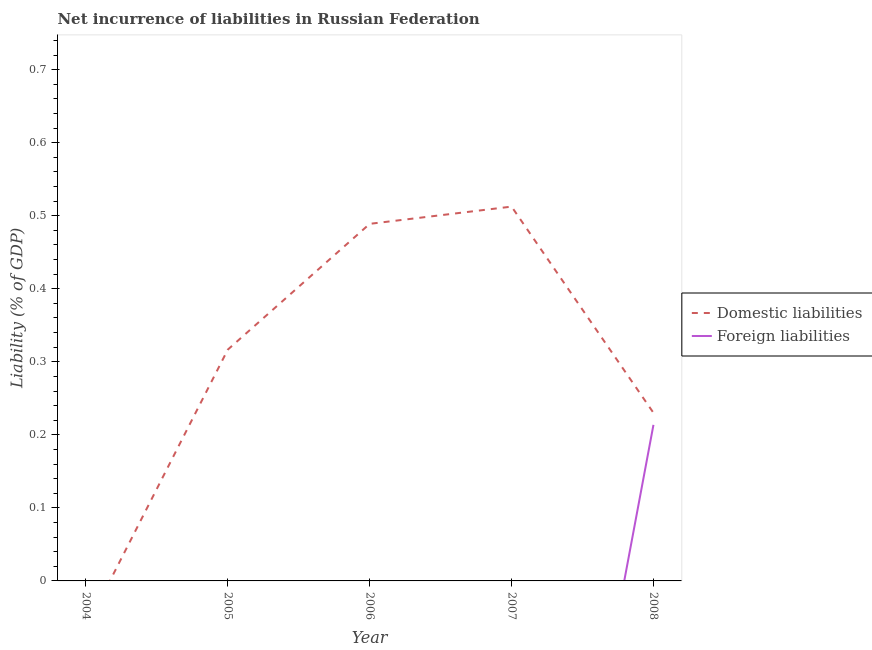How many different coloured lines are there?
Offer a terse response. 2. Does the line corresponding to incurrence of foreign liabilities intersect with the line corresponding to incurrence of domestic liabilities?
Ensure brevity in your answer.  No. What is the incurrence of foreign liabilities in 2008?
Give a very brief answer. 0.21. Across all years, what is the maximum incurrence of foreign liabilities?
Provide a succinct answer. 0.21. Across all years, what is the minimum incurrence of domestic liabilities?
Ensure brevity in your answer.  0. In which year was the incurrence of domestic liabilities maximum?
Your answer should be very brief. 2007. What is the total incurrence of foreign liabilities in the graph?
Keep it short and to the point. 0.21. What is the difference between the incurrence of domestic liabilities in 2005 and that in 2007?
Provide a succinct answer. -0.2. What is the average incurrence of foreign liabilities per year?
Offer a terse response. 0.04. In the year 2008, what is the difference between the incurrence of domestic liabilities and incurrence of foreign liabilities?
Keep it short and to the point. 0.02. In how many years, is the incurrence of domestic liabilities greater than 0.04 %?
Give a very brief answer. 4. What is the difference between the highest and the second highest incurrence of domestic liabilities?
Give a very brief answer. 0.02. What is the difference between the highest and the lowest incurrence of domestic liabilities?
Offer a very short reply. 0.51. Is the sum of the incurrence of domestic liabilities in 2006 and 2008 greater than the maximum incurrence of foreign liabilities across all years?
Ensure brevity in your answer.  Yes. Does the incurrence of domestic liabilities monotonically increase over the years?
Your answer should be very brief. No. Is the incurrence of domestic liabilities strictly less than the incurrence of foreign liabilities over the years?
Keep it short and to the point. No. How many years are there in the graph?
Make the answer very short. 5. Where does the legend appear in the graph?
Offer a very short reply. Center right. How many legend labels are there?
Offer a very short reply. 2. How are the legend labels stacked?
Ensure brevity in your answer.  Vertical. What is the title of the graph?
Keep it short and to the point. Net incurrence of liabilities in Russian Federation. What is the label or title of the Y-axis?
Provide a short and direct response. Liability (% of GDP). What is the Liability (% of GDP) of Domestic liabilities in 2004?
Make the answer very short. 0. What is the Liability (% of GDP) of Foreign liabilities in 2004?
Ensure brevity in your answer.  0. What is the Liability (% of GDP) of Domestic liabilities in 2005?
Keep it short and to the point. 0.32. What is the Liability (% of GDP) in Foreign liabilities in 2005?
Provide a short and direct response. 0. What is the Liability (% of GDP) in Domestic liabilities in 2006?
Offer a terse response. 0.49. What is the Liability (% of GDP) in Foreign liabilities in 2006?
Your answer should be compact. 0. What is the Liability (% of GDP) of Domestic liabilities in 2007?
Provide a succinct answer. 0.51. What is the Liability (% of GDP) of Foreign liabilities in 2007?
Offer a terse response. 0. What is the Liability (% of GDP) in Domestic liabilities in 2008?
Offer a terse response. 0.23. What is the Liability (% of GDP) in Foreign liabilities in 2008?
Provide a succinct answer. 0.21. Across all years, what is the maximum Liability (% of GDP) of Domestic liabilities?
Make the answer very short. 0.51. Across all years, what is the maximum Liability (% of GDP) in Foreign liabilities?
Offer a very short reply. 0.21. Across all years, what is the minimum Liability (% of GDP) of Domestic liabilities?
Provide a succinct answer. 0. What is the total Liability (% of GDP) in Domestic liabilities in the graph?
Provide a short and direct response. 1.55. What is the total Liability (% of GDP) of Foreign liabilities in the graph?
Your answer should be compact. 0.21. What is the difference between the Liability (% of GDP) in Domestic liabilities in 2005 and that in 2006?
Provide a short and direct response. -0.17. What is the difference between the Liability (% of GDP) of Domestic liabilities in 2005 and that in 2007?
Ensure brevity in your answer.  -0.2. What is the difference between the Liability (% of GDP) in Domestic liabilities in 2005 and that in 2008?
Make the answer very short. 0.09. What is the difference between the Liability (% of GDP) of Domestic liabilities in 2006 and that in 2007?
Give a very brief answer. -0.02. What is the difference between the Liability (% of GDP) of Domestic liabilities in 2006 and that in 2008?
Your answer should be very brief. 0.26. What is the difference between the Liability (% of GDP) in Domestic liabilities in 2007 and that in 2008?
Ensure brevity in your answer.  0.28. What is the difference between the Liability (% of GDP) of Domestic liabilities in 2005 and the Liability (% of GDP) of Foreign liabilities in 2008?
Provide a succinct answer. 0.1. What is the difference between the Liability (% of GDP) of Domestic liabilities in 2006 and the Liability (% of GDP) of Foreign liabilities in 2008?
Provide a succinct answer. 0.28. What is the difference between the Liability (% of GDP) in Domestic liabilities in 2007 and the Liability (% of GDP) in Foreign liabilities in 2008?
Your answer should be very brief. 0.3. What is the average Liability (% of GDP) of Domestic liabilities per year?
Give a very brief answer. 0.31. What is the average Liability (% of GDP) of Foreign liabilities per year?
Offer a very short reply. 0.04. In the year 2008, what is the difference between the Liability (% of GDP) in Domestic liabilities and Liability (% of GDP) in Foreign liabilities?
Your response must be concise. 0.02. What is the ratio of the Liability (% of GDP) in Domestic liabilities in 2005 to that in 2006?
Provide a succinct answer. 0.65. What is the ratio of the Liability (% of GDP) in Domestic liabilities in 2005 to that in 2007?
Your response must be concise. 0.62. What is the ratio of the Liability (% of GDP) in Domestic liabilities in 2005 to that in 2008?
Your answer should be compact. 1.38. What is the ratio of the Liability (% of GDP) in Domestic liabilities in 2006 to that in 2007?
Provide a succinct answer. 0.95. What is the ratio of the Liability (% of GDP) of Domestic liabilities in 2006 to that in 2008?
Offer a terse response. 2.12. What is the ratio of the Liability (% of GDP) of Domestic liabilities in 2007 to that in 2008?
Provide a succinct answer. 2.23. What is the difference between the highest and the second highest Liability (% of GDP) of Domestic liabilities?
Make the answer very short. 0.02. What is the difference between the highest and the lowest Liability (% of GDP) in Domestic liabilities?
Offer a terse response. 0.51. What is the difference between the highest and the lowest Liability (% of GDP) of Foreign liabilities?
Your response must be concise. 0.21. 